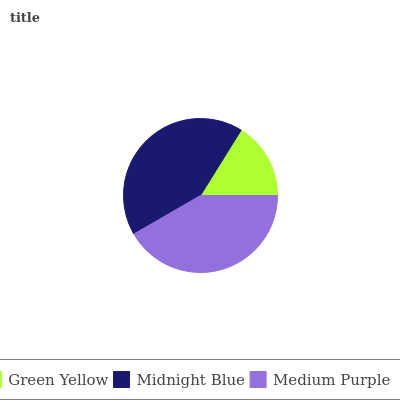Is Green Yellow the minimum?
Answer yes or no. Yes. Is Midnight Blue the maximum?
Answer yes or no. Yes. Is Medium Purple the minimum?
Answer yes or no. No. Is Medium Purple the maximum?
Answer yes or no. No. Is Midnight Blue greater than Medium Purple?
Answer yes or no. Yes. Is Medium Purple less than Midnight Blue?
Answer yes or no. Yes. Is Medium Purple greater than Midnight Blue?
Answer yes or no. No. Is Midnight Blue less than Medium Purple?
Answer yes or no. No. Is Medium Purple the high median?
Answer yes or no. Yes. Is Medium Purple the low median?
Answer yes or no. Yes. Is Green Yellow the high median?
Answer yes or no. No. Is Green Yellow the low median?
Answer yes or no. No. 